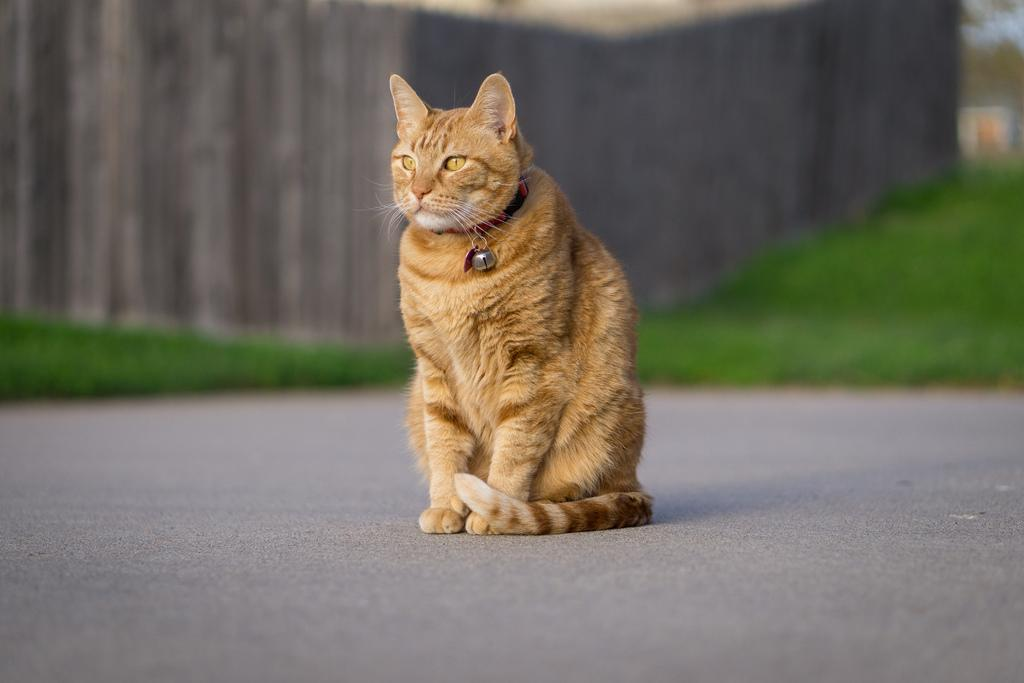What animal can be seen in the image? There is a cat in the image. Where is the cat located in the image? The cat is sitting on the road. Can you describe the background of the image? The background of the image is blurred. What color is present in the image? Green color is present in the image. Are there any protesters wearing masks in the image? There are no protesters or masks present in the image; it features a cat sitting on the road. How is the cat controlling the traffic in the image? The cat is not controlling the traffic in the image; it is simply sitting on the road. 